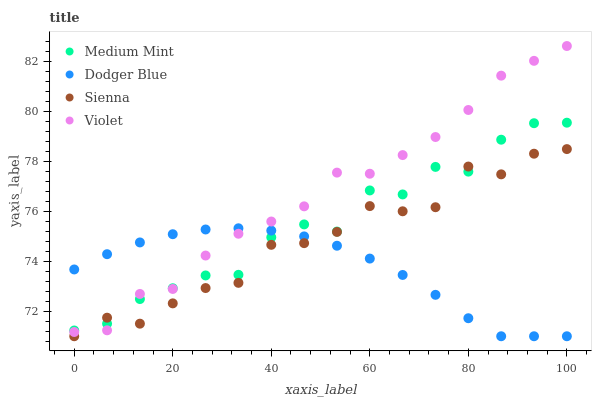Does Dodger Blue have the minimum area under the curve?
Answer yes or no. Yes. Does Violet have the maximum area under the curve?
Answer yes or no. Yes. Does Sienna have the minimum area under the curve?
Answer yes or no. No. Does Sienna have the maximum area under the curve?
Answer yes or no. No. Is Dodger Blue the smoothest?
Answer yes or no. Yes. Is Medium Mint the roughest?
Answer yes or no. Yes. Is Sienna the smoothest?
Answer yes or no. No. Is Sienna the roughest?
Answer yes or no. No. Does Sienna have the lowest value?
Answer yes or no. Yes. Does Violet have the lowest value?
Answer yes or no. No. Does Violet have the highest value?
Answer yes or no. Yes. Does Sienna have the highest value?
Answer yes or no. No. Does Violet intersect Sienna?
Answer yes or no. Yes. Is Violet less than Sienna?
Answer yes or no. No. Is Violet greater than Sienna?
Answer yes or no. No. 